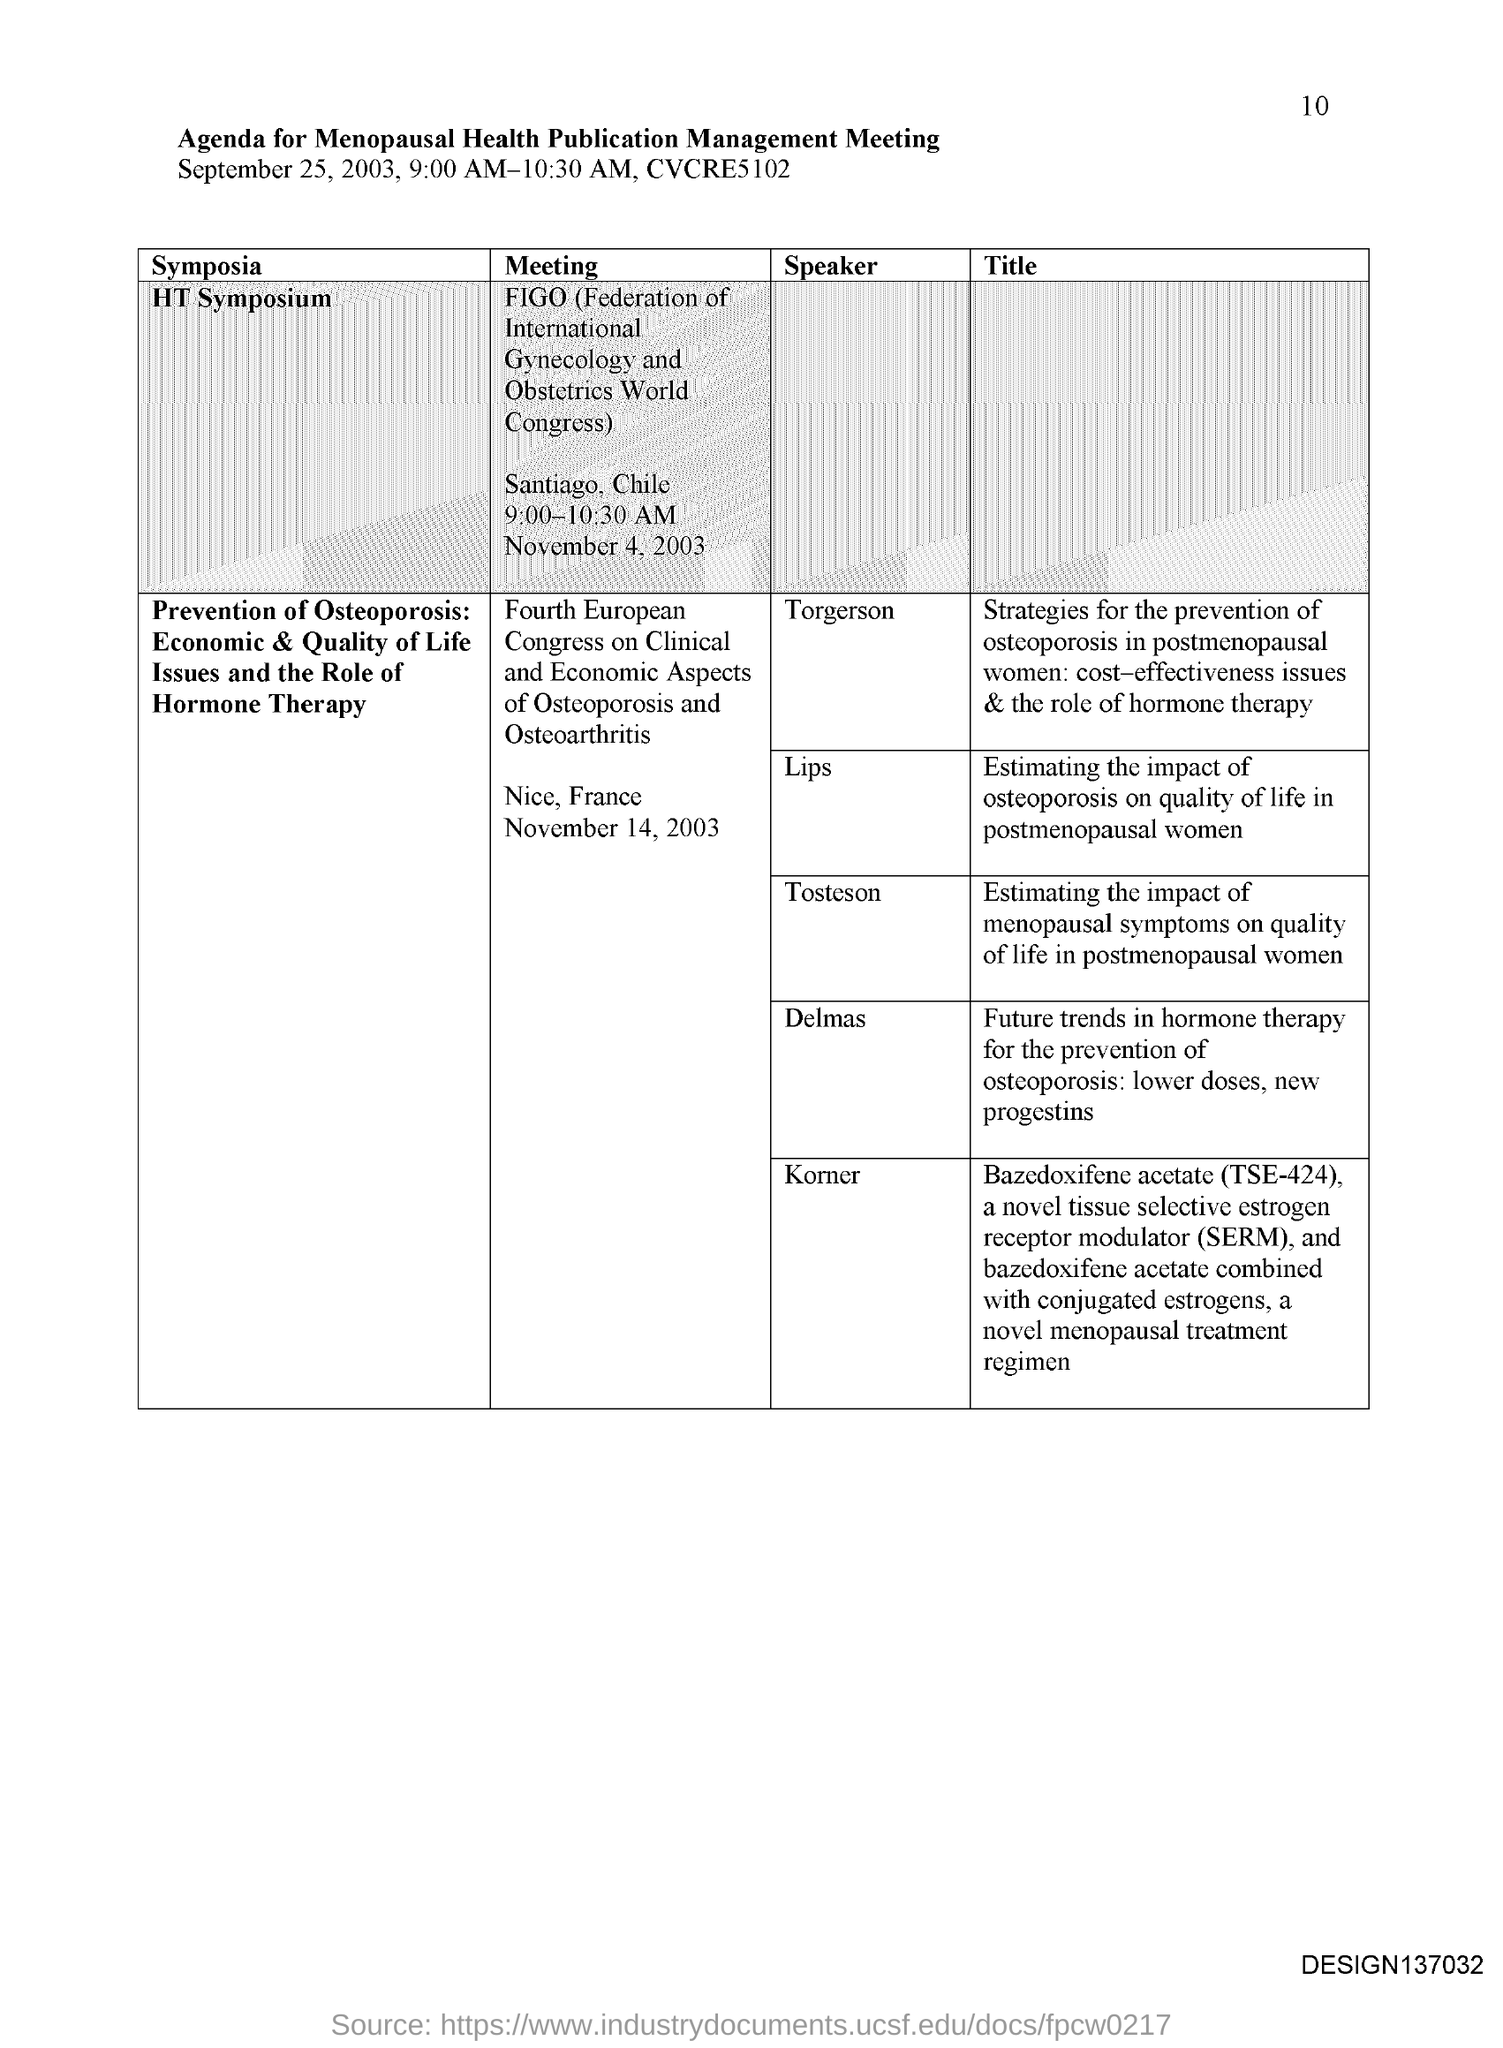Indicate a few pertinent items in this graphic. The document in question is titled "Agenda for Menopausal health publication management meeting. SERM stands for selective estrogen receptor modulator. The page number is 10. The full form of FIGO is the Federation of International Gynecology and Obstetrics World Congress. 